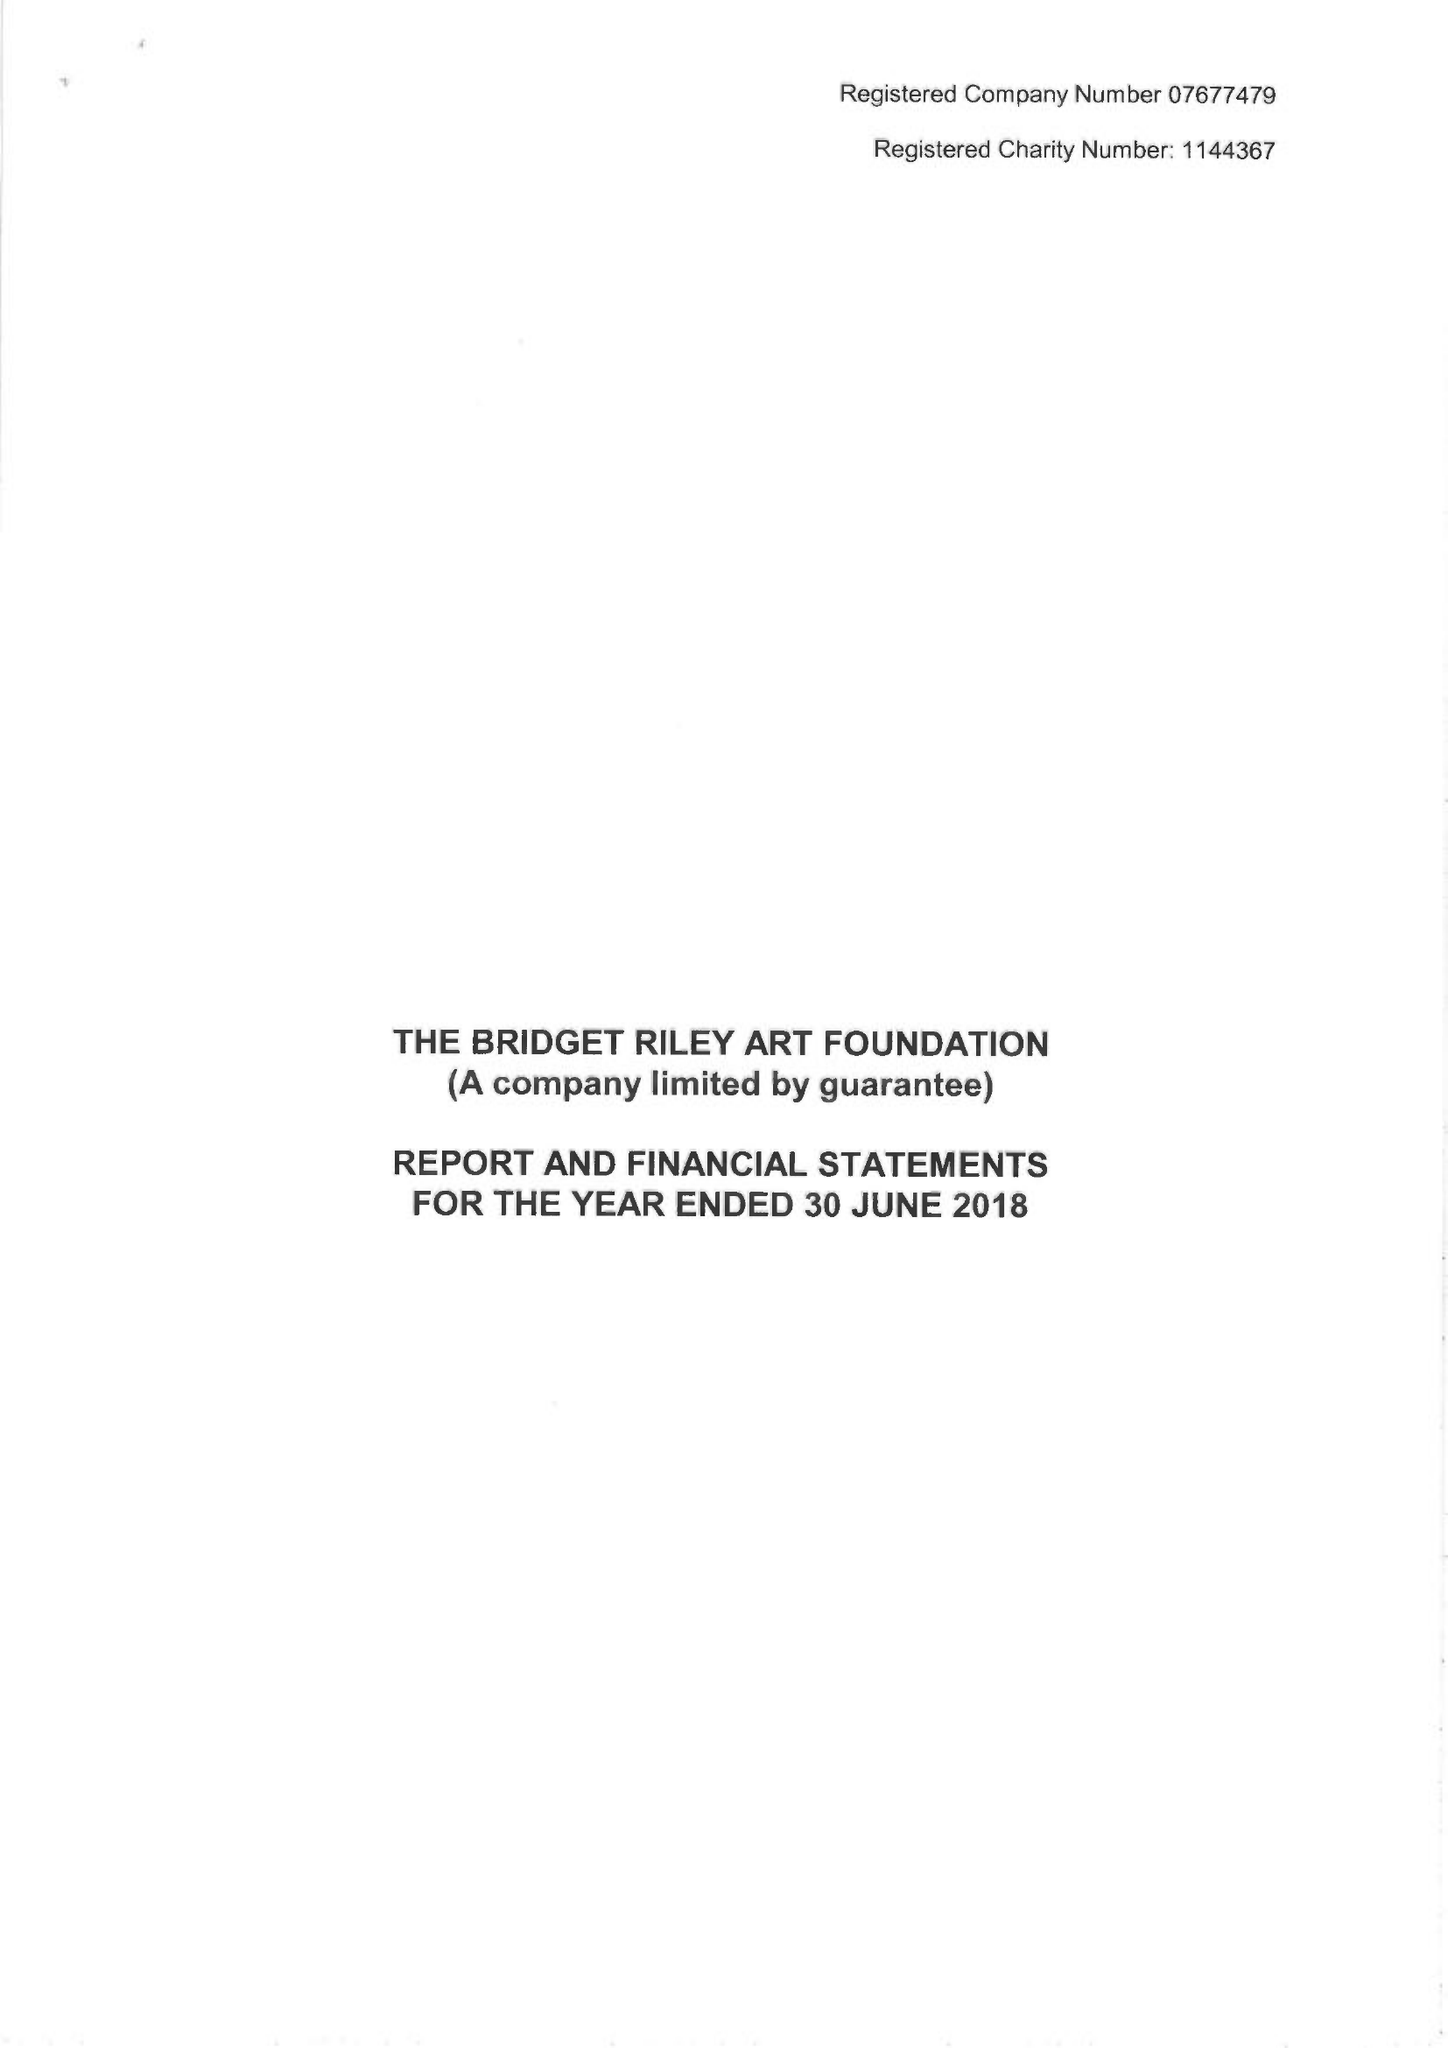What is the value for the charity_number?
Answer the question using a single word or phrase. 1144367 